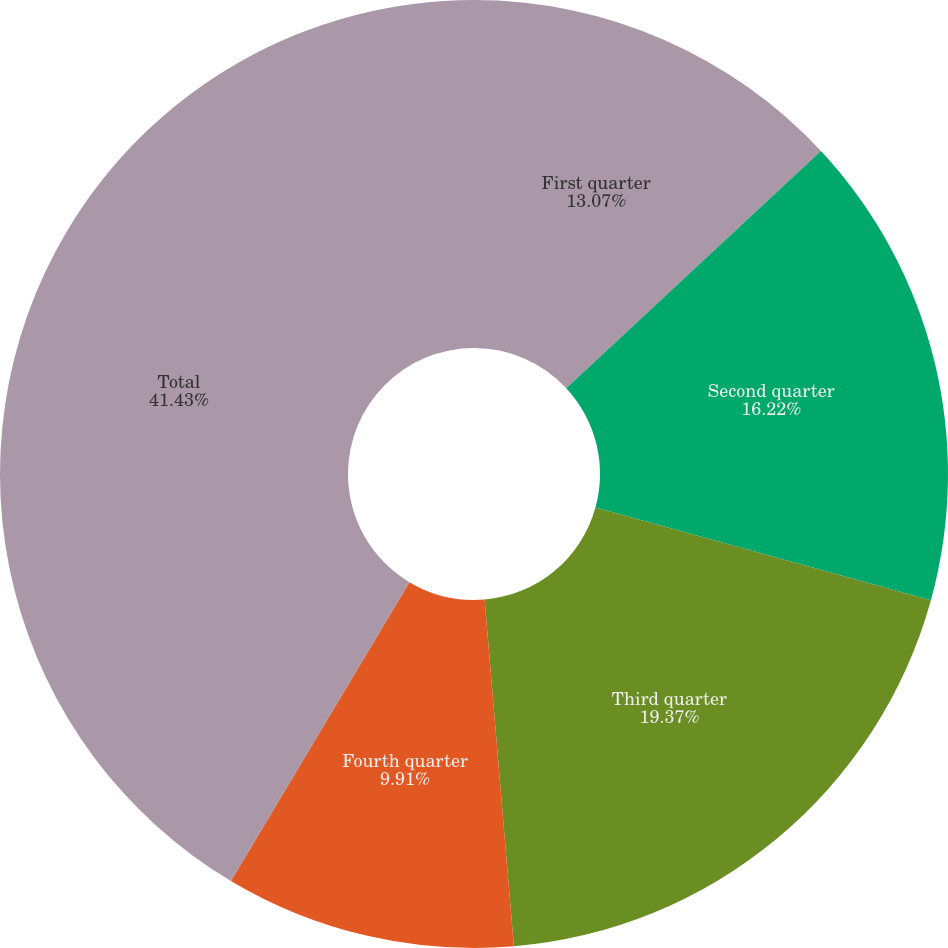Convert chart to OTSL. <chart><loc_0><loc_0><loc_500><loc_500><pie_chart><fcel>First quarter<fcel>Second quarter<fcel>Third quarter<fcel>Fourth quarter<fcel>Total<nl><fcel>13.07%<fcel>16.22%<fcel>19.37%<fcel>9.91%<fcel>41.43%<nl></chart> 